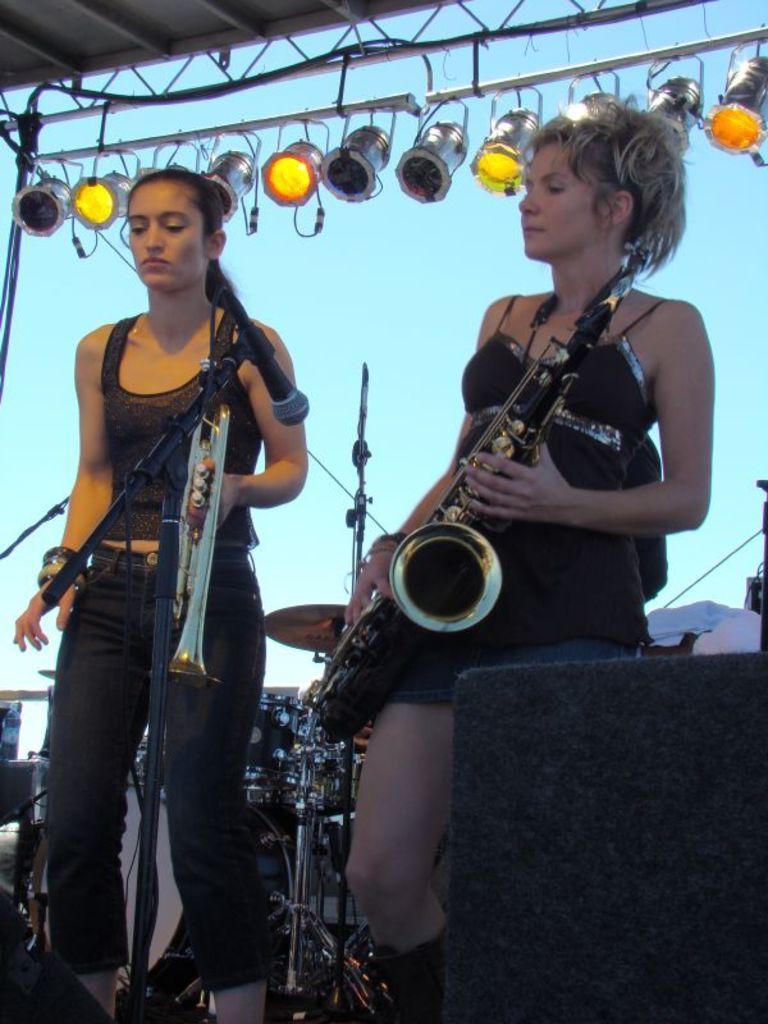How would you summarize this image in a sentence or two? Here I can see two women standing and holding the musical instruments in the hands. In front of these people there is a mike stand. In the background there is a drum set. In the bottom right there is a black color box. At the top of the image I can see few lights are attached to a metal rod. In the background, I can see the sky. 